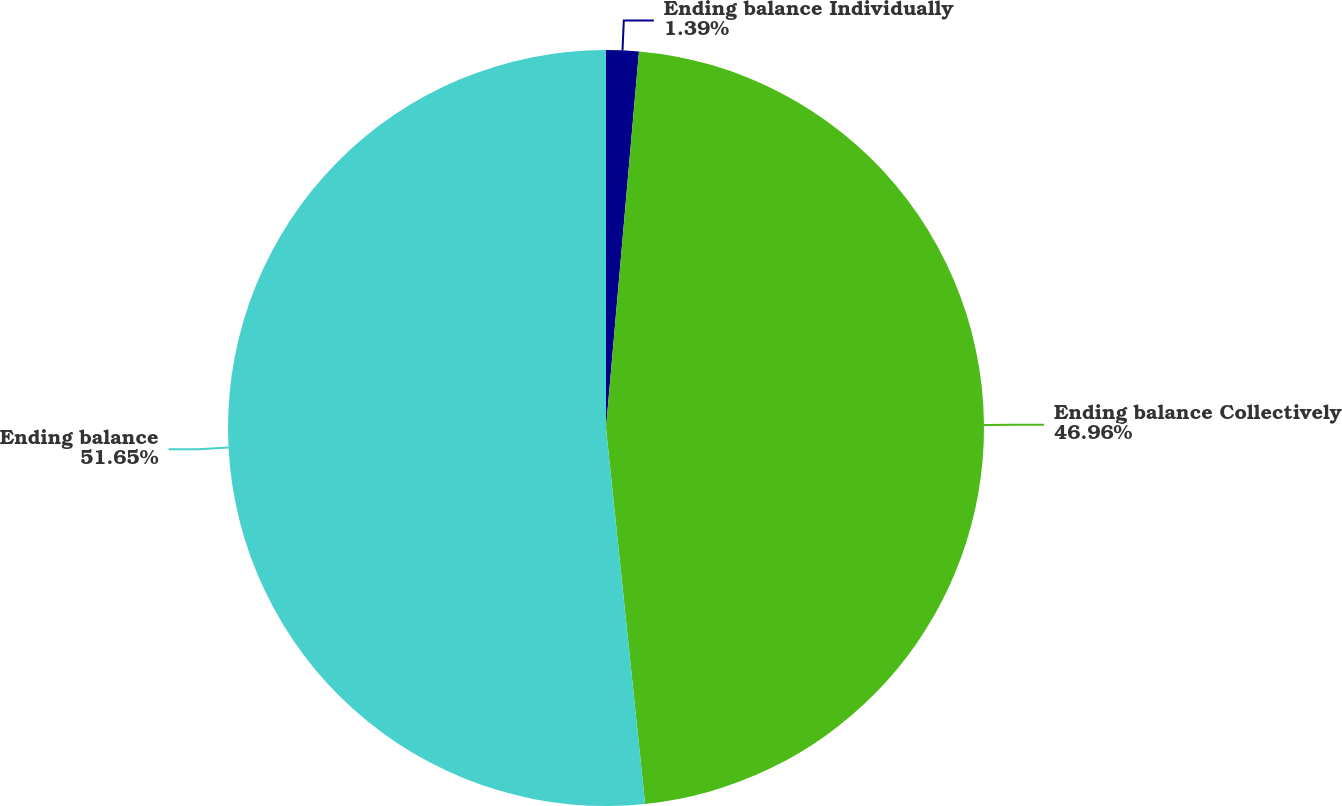<chart> <loc_0><loc_0><loc_500><loc_500><pie_chart><fcel>Ending balance Individually<fcel>Ending balance Collectively<fcel>Ending balance<nl><fcel>1.39%<fcel>46.96%<fcel>51.65%<nl></chart> 